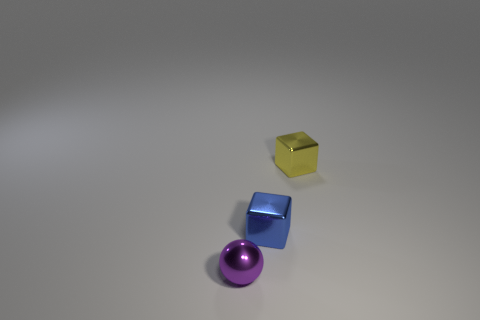What number of purple metallic things are behind the yellow cube?
Your answer should be very brief. 0. Are there any small blue objects made of the same material as the yellow object?
Offer a very short reply. Yes. What material is the other block that is the same size as the blue metal cube?
Your answer should be compact. Metal. Is the blue block made of the same material as the tiny purple thing?
Keep it short and to the point. Yes. How many things are either large blue matte spheres or small blue metal blocks?
Give a very brief answer. 1. What shape is the blue thing that is in front of the yellow metallic thing?
Provide a succinct answer. Cube. The cube that is the same material as the yellow object is what color?
Give a very brief answer. Blue. There is a blue object that is the same shape as the yellow metallic object; what is its material?
Your answer should be compact. Metal. There is a yellow thing; what shape is it?
Your response must be concise. Cube. What is the tiny thing that is in front of the tiny yellow thing and to the right of the tiny sphere made of?
Provide a short and direct response. Metal. 